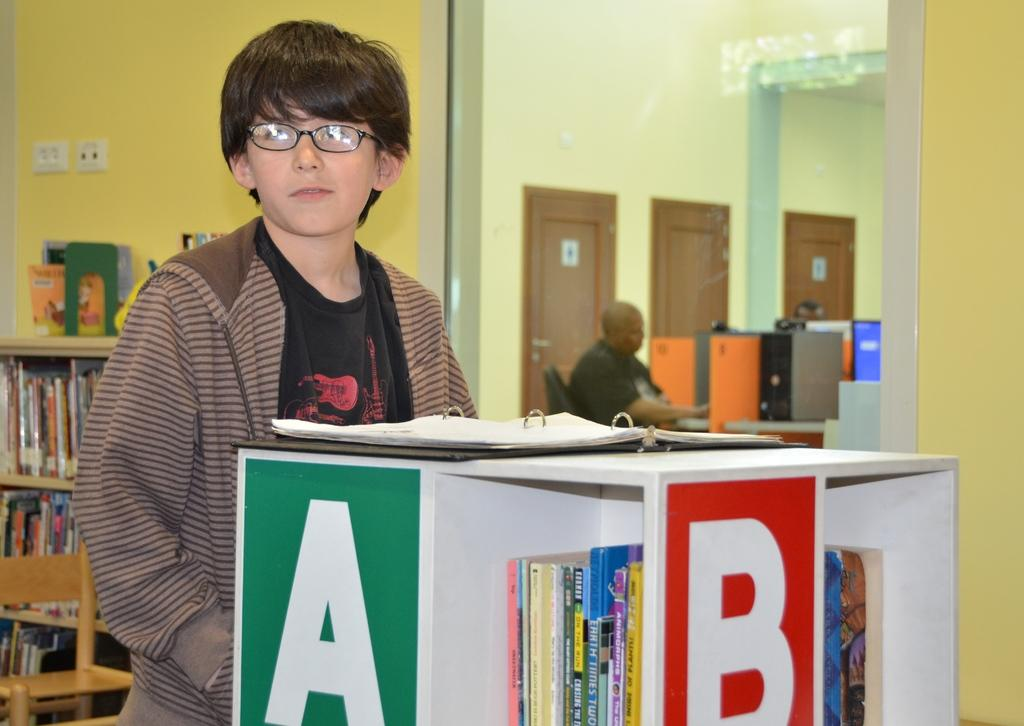Provide a one-sentence caption for the provided image. A young boy stands in front of a shelf with the letters A and B on it. 